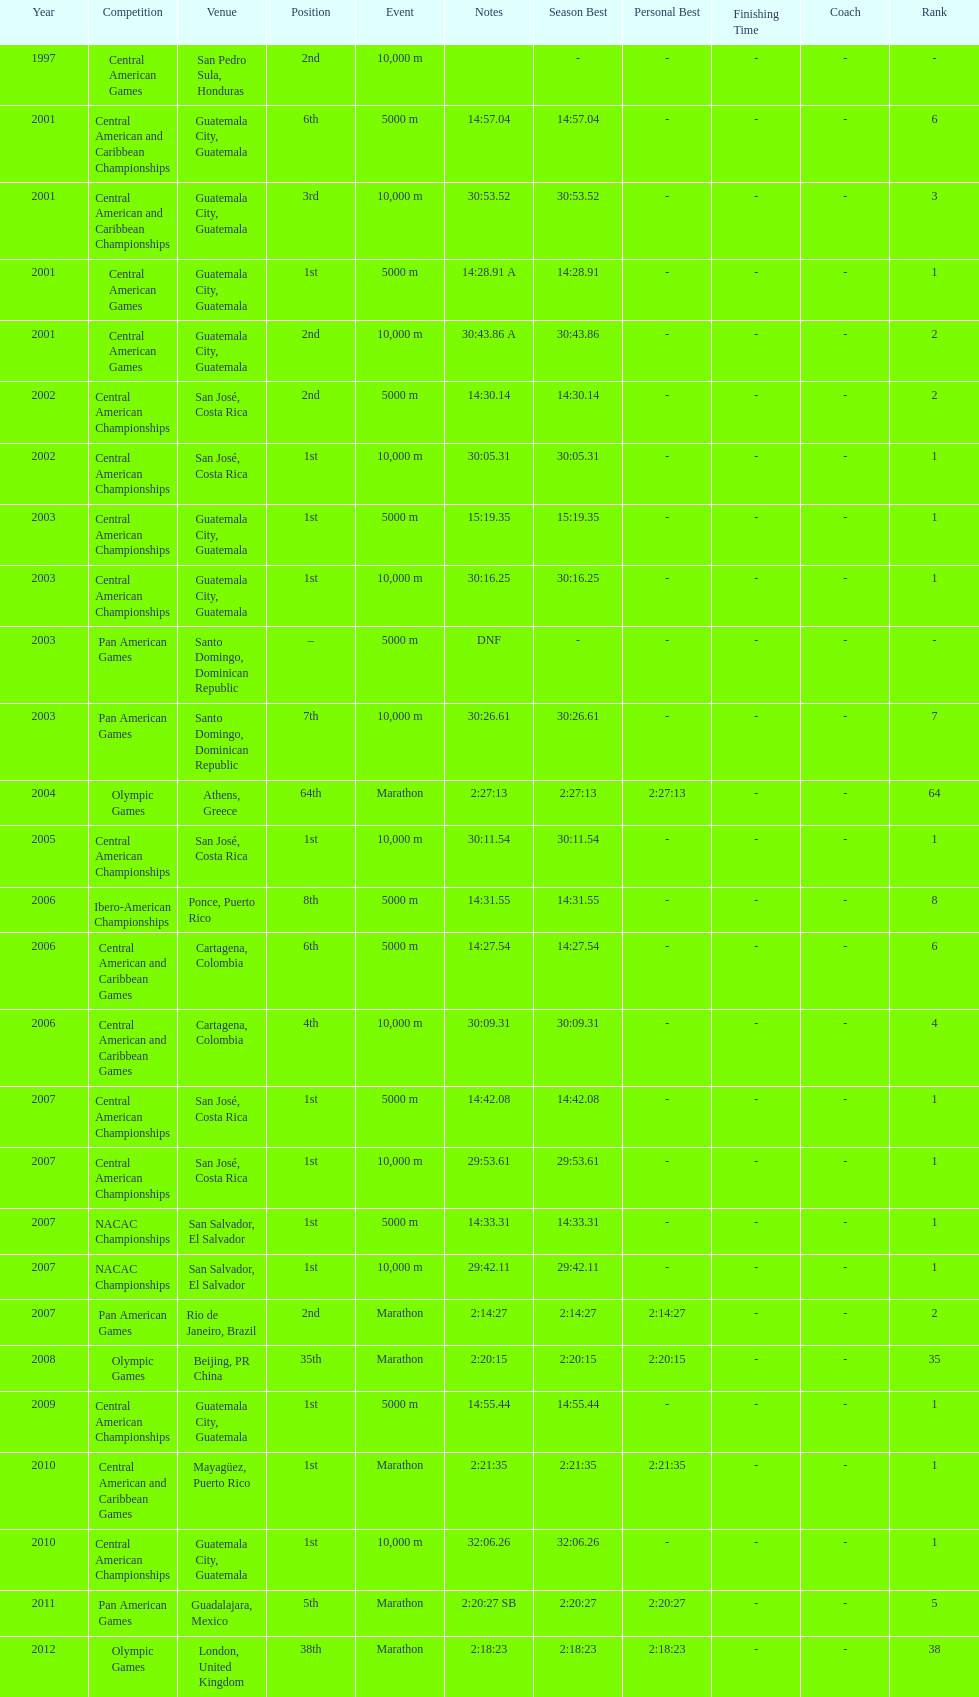Tell me the number of times they competed in guatamala. 5. 